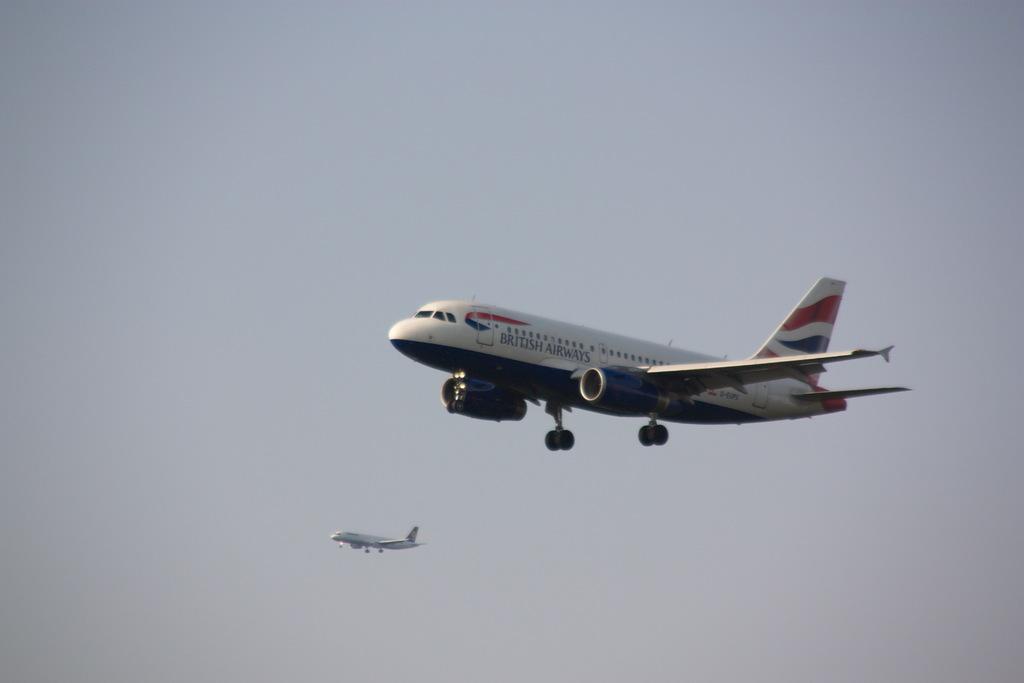Can you describe this image briefly? This picture is clicked outside. In the center we can see the two airplanes flying in the sky. In the background there is a sky. 